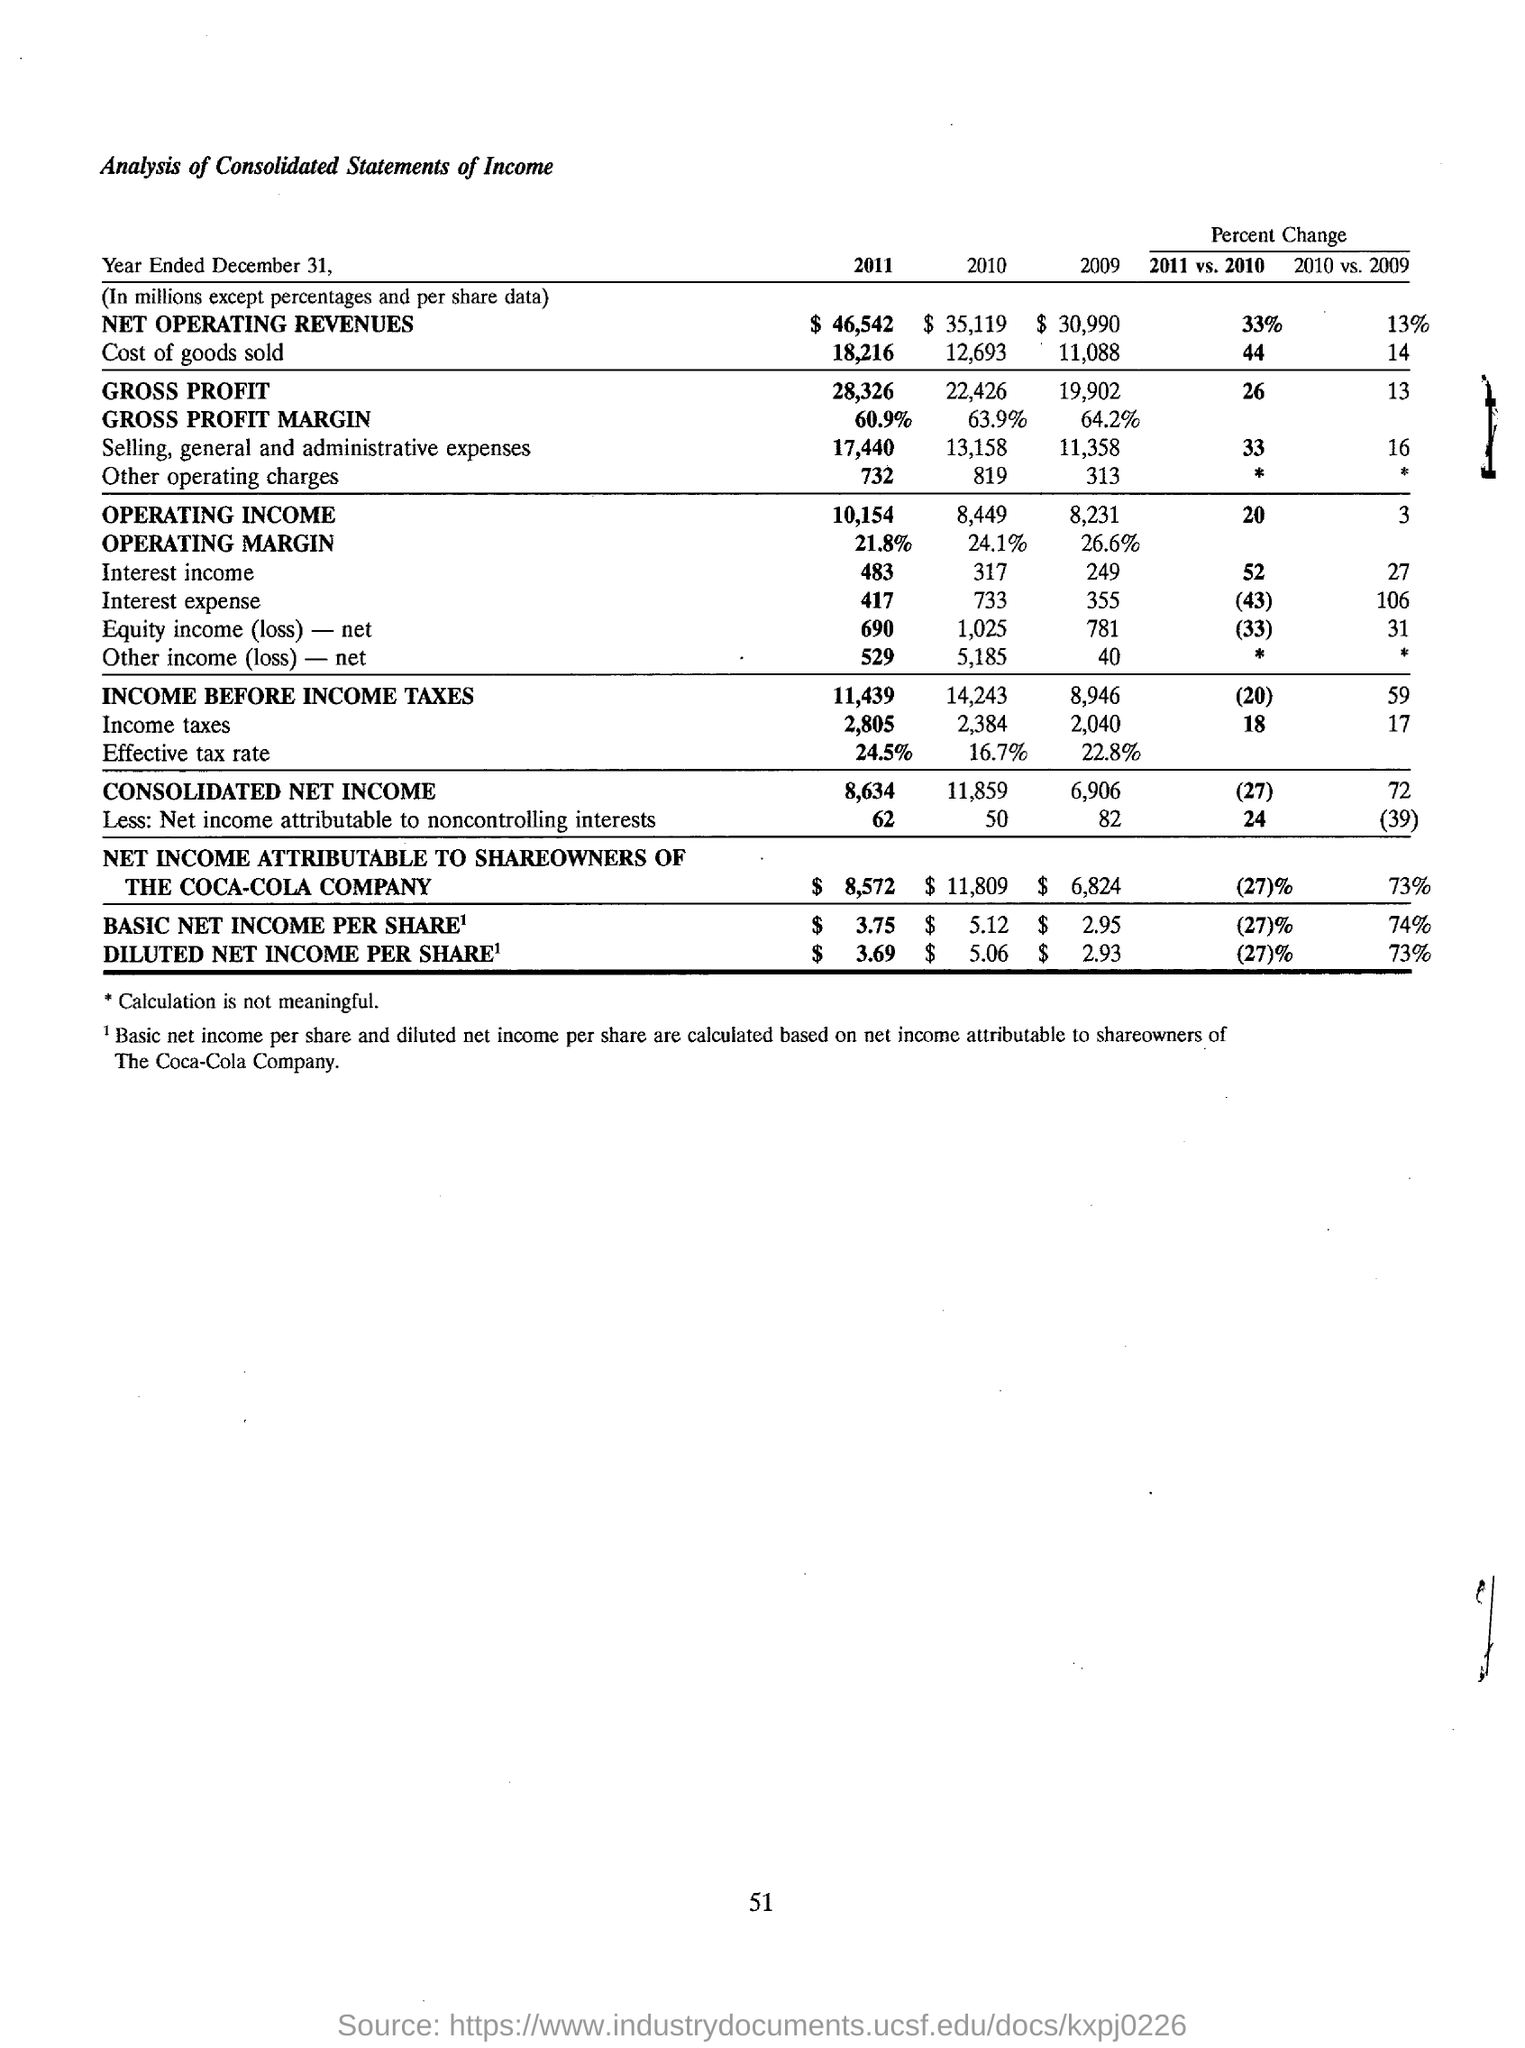What is the effective tax rate for the year 2011?
Keep it short and to the point. 24.5%. What is the amount of net operating revenues for the year 2010?
Give a very brief answer. $ 35,119. What is the gross profit margin for the year 2009?
Your answer should be compact. 64.2%. What is the consolidated net income for the year 2010?
Provide a succinct answer. 11,859. What is the basic net income per share for the year 2011?
Keep it short and to the point. $  3.75. What is the diluted net income per share for the year 2010?
Make the answer very short. $ 5.06. On what basis, the basic net income per share and diluted net income per share are calculated?
Your response must be concise. Based on net income attributable to shareowners of The Coca-Cola Company. What is the consolidated net income for the year 2011?
Your answer should be compact. 8,634. What kind of analysis is done here?
Provide a short and direct response. Analysis of Consolidated Statements of Income. 